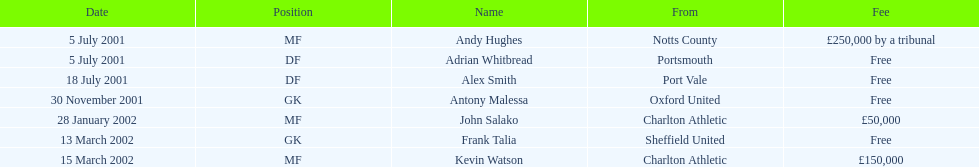Andy huges and adrian whitbread both tranfered on which date? 5 July 2001. 